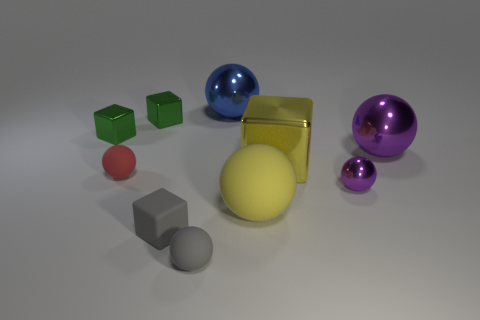Subtract all yellow spheres. How many spheres are left? 5 Subtract all tiny gray matte spheres. How many spheres are left? 5 Subtract all gray spheres. Subtract all brown cylinders. How many spheres are left? 5 Subtract all blocks. How many objects are left? 6 Add 3 small red matte spheres. How many small red matte spheres exist? 4 Subtract 0 cyan cylinders. How many objects are left? 10 Subtract all metallic spheres. Subtract all small things. How many objects are left? 1 Add 1 blue things. How many blue things are left? 2 